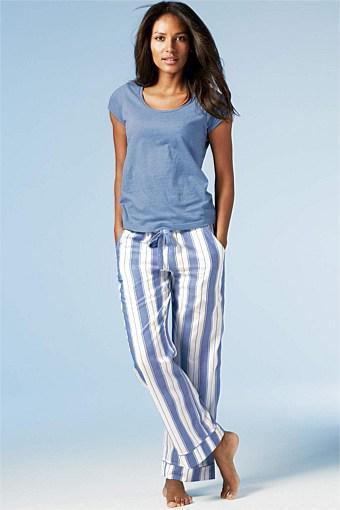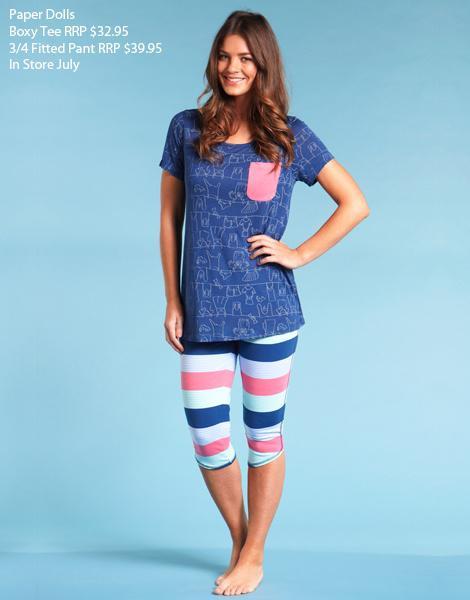The first image is the image on the left, the second image is the image on the right. For the images shown, is this caption "One solid color pajama set has a top with straps and lacy bra area, as well as a very short matching bottom." true? Answer yes or no. No. The first image is the image on the left, the second image is the image on the right. Examine the images to the left and right. Is the description "A model wears a long-sleeved robe-type cover-up over intimate apparel in one image." accurate? Answer yes or no. No. 